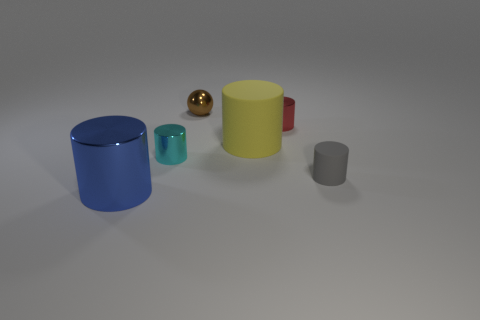Are these objects arranged in a particular pattern? The objects are not arranged in a strict pattern, but they seem to be intentionally placed in relation to one another, creating a balanced composition. The varying sizes and colors seem to guide the viewer's eye through the scene, from the largest at one end to the smallest at the other, almost forming an arc. 